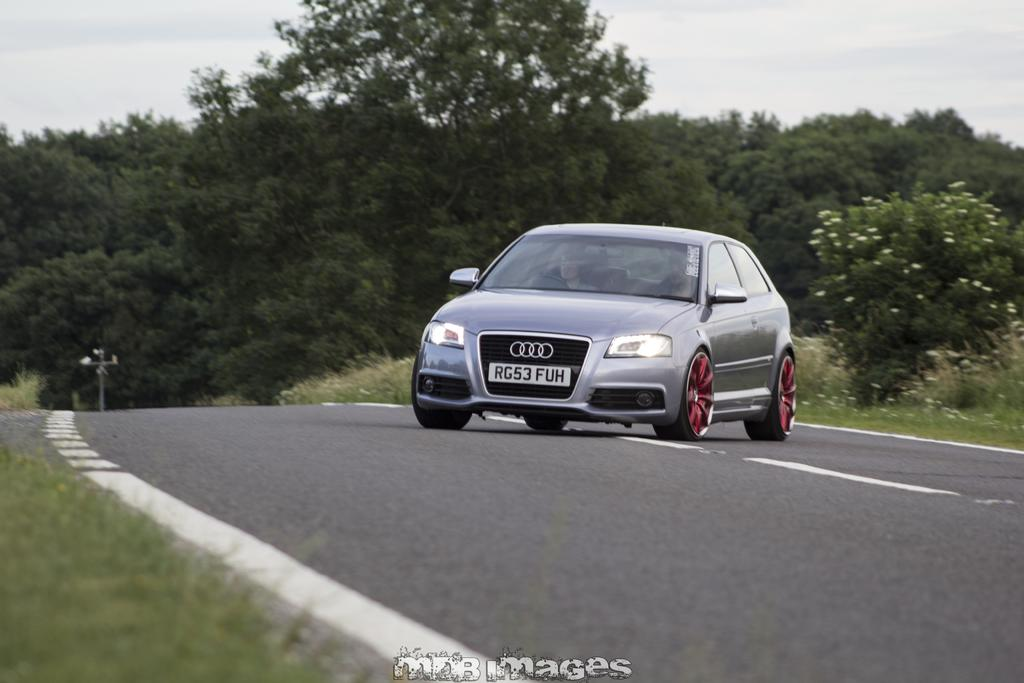What is the main subject of the image? There is a car in the image. Where is the car located? The car is on the road. What can be seen in the background of the image? There are trees in the background of the image. How many chickens are crossing the road in the image? There are no chickens present in the image. What type of oil is being used to lubricate the car in the image? There is no information about the car's oil in the image. 